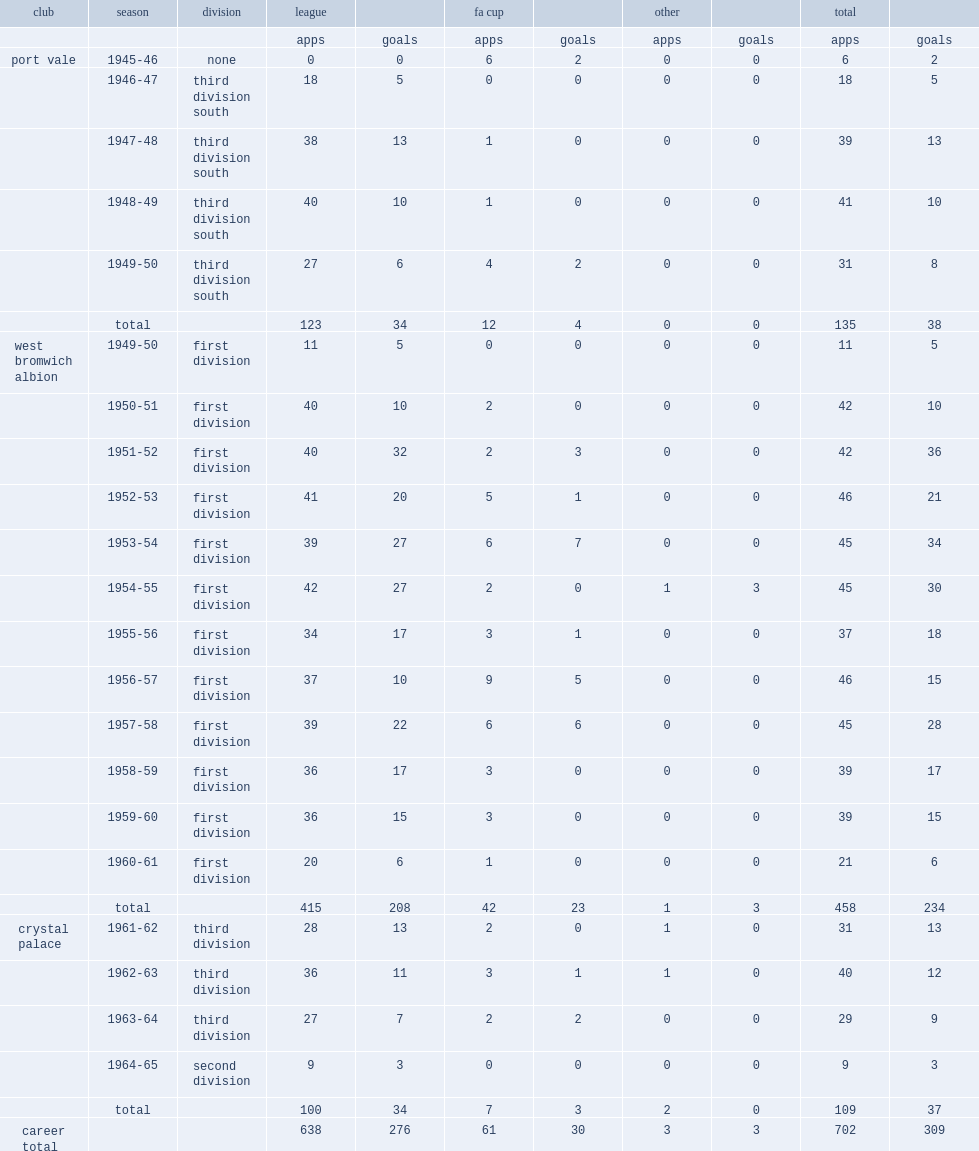How many goals did ronnie allen score in the football league. 276.0. 